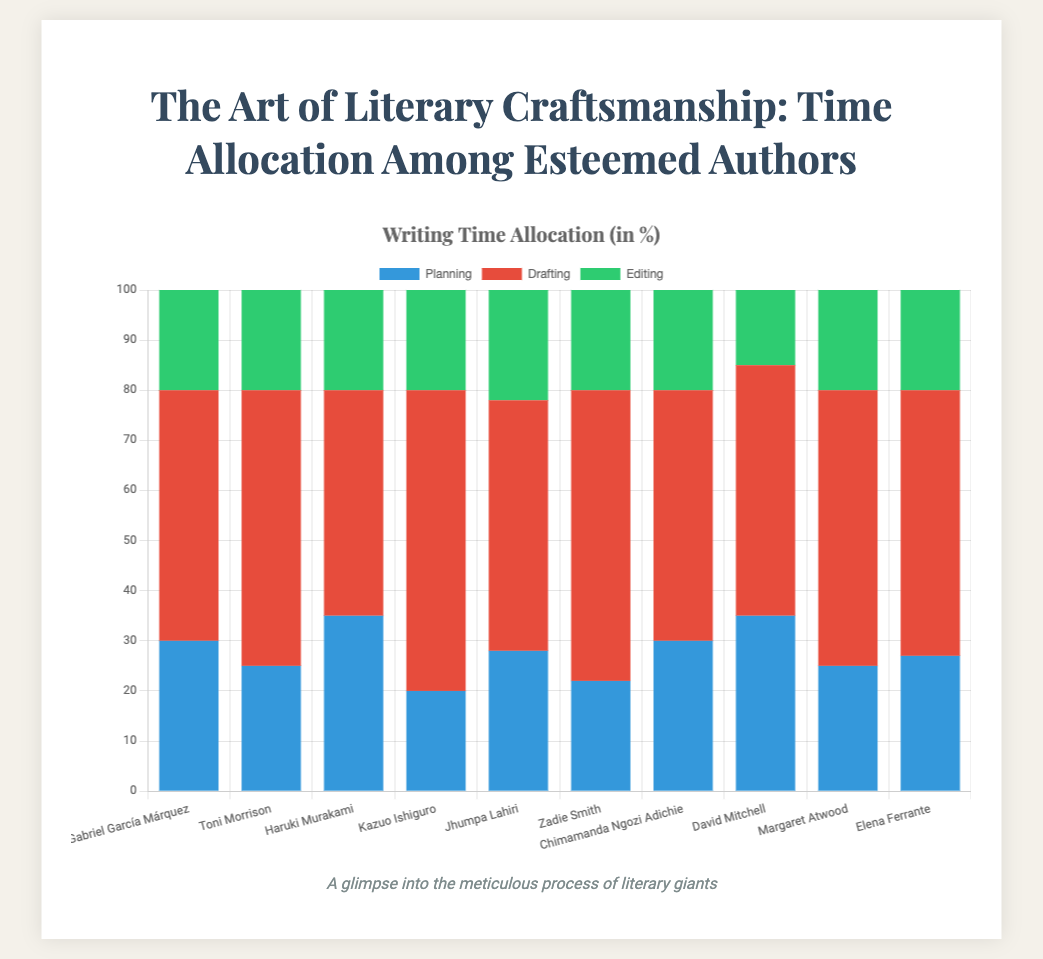How many authors allocate more time to drafting compared to planning? To determine how many authors allocate more time to drafting compared to planning, look at each author's allocation for drafting and check if it is greater than their planning allocation. There are 10 authors, and all have higher or equal drafting allocations than planning: 50 > 30, 55 > 25, 45 > 35, 60 > 20, 50 > 28, 58 > 22, 50 > 30, 50 > 35, 55 > 25, 53 > 27. Therefore, there are 9 authors where drafting > planning.
Answer: 9 Which author spends the least amount of time on planning? Compare the 'Planning' allocations for all authors. The smallest value is 20 for Kazuo Ishiguro.
Answer: Kazuo Ishiguro What is the total time spent on editing by all authors combined? Sum up the 'Editing' times for each author: 20 + 20 + 20 + 20 + 22 + 20 + 20 + 15 + 20 + 20. Therefore, the total is 197.
Answer: 197 Who spends the most time planning their work? Compare the 'Planning' allocations for all authors. The highest value is 35 for both Haruki Murakami and David Mitchell.
Answer: Haruki Murakami and David Mitchell What is the average time dedicated to drafting across all authors? Add up all the 'Drafting' times and divide by the number of authors: (50 + 55 + 45 + 60 + 50 + 58 + 50 + 50 + 55 + 53) / 10, which results in 52.6.
Answer: 52.6 Between Toni Morrison and Zadie Smith, who allocates more time to drafting, and by how much? Toni Morrison allocates 55% and Zadie Smith allocates 58%. To find the difference: 58 - 55 = 3. Zadie Smith spends 3% more on drafting than Toni Morrison.
Answer: Zadie Smith by 3 What is the proportion of planning time to the total time spent on the writing process for Margaret Atwood? The total writing time is 100% (Planning + Drafting + Editing = 25 + 55 + 20). The proportion of planning time is (25/100) * 100%.
Answer: 25% Who are the authors who spend an equal amount of time on editing? Look for authors with the same 'Editing' allocation. Several authors, Gabriel García Márquez, Toni Morrison, Haruki Murakami, Kazuo Ishiguro, Zadie Smith, Chimamanda Ngozi Adichie, Margaret Atwood, and Elena Ferrante, all have an editing allocation of 20.
Answer: Gabriel García Márquez, Toni Morrison, Haruki Murakami, Kazuo Ishiguro, Zadie Smith, Chimamanda Ngozi Adichie, Margaret Atwood, Elena Ferrante 